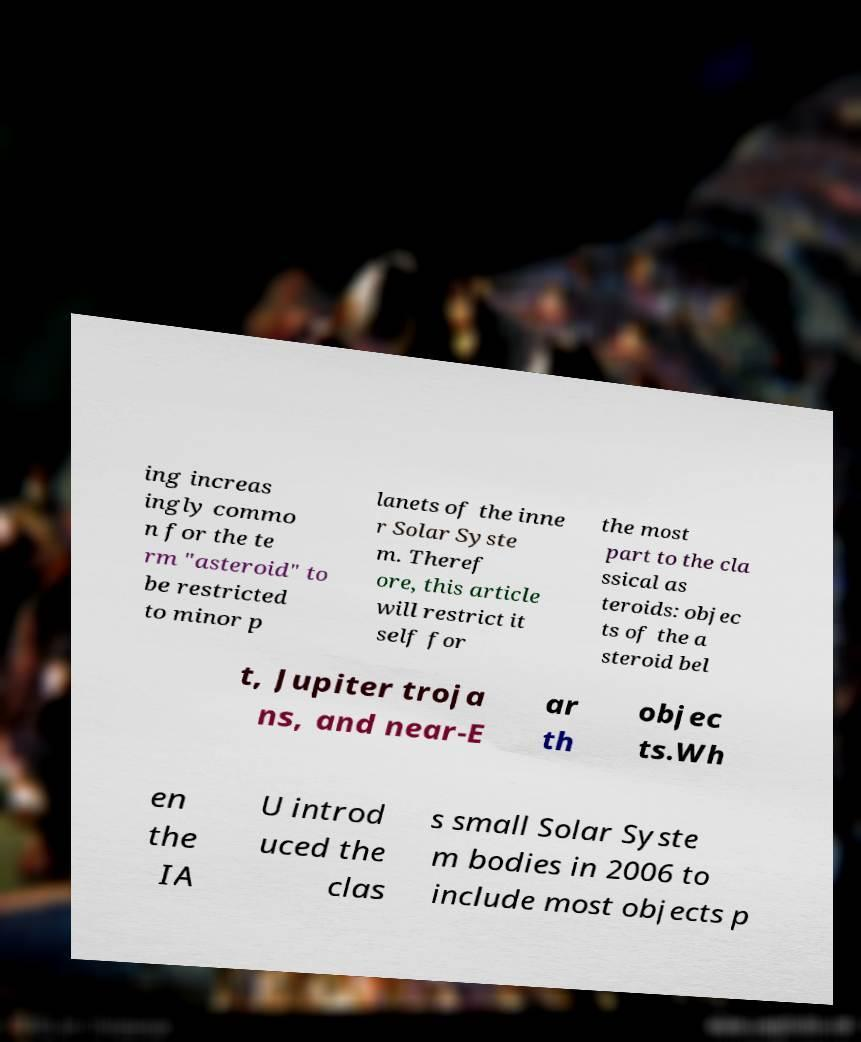Could you assist in decoding the text presented in this image and type it out clearly? ing increas ingly commo n for the te rm "asteroid" to be restricted to minor p lanets of the inne r Solar Syste m. Theref ore, this article will restrict it self for the most part to the cla ssical as teroids: objec ts of the a steroid bel t, Jupiter troja ns, and near-E ar th objec ts.Wh en the IA U introd uced the clas s small Solar Syste m bodies in 2006 to include most objects p 